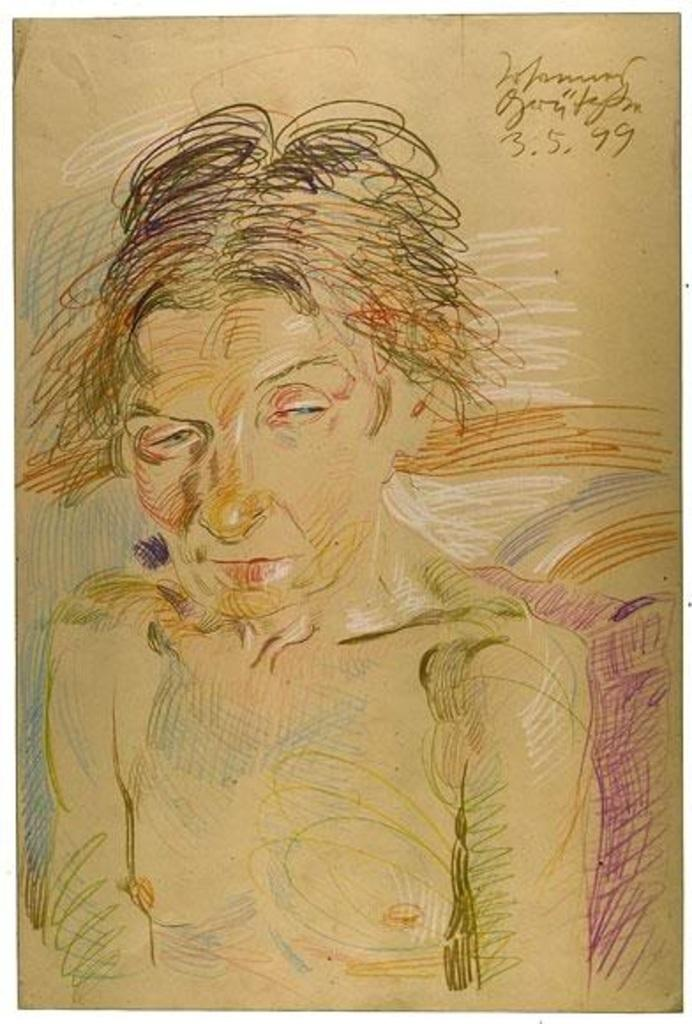What is depicted in the image? There is a drawing of a woman in the image. What is the woman doing in the drawing? The woman is leaning on a pillow in the drawing. Where is the woman located in the drawing? The woman is on a platform in the drawing. What additional information can be found on the platform? There are texts written on the platform in the top right corner of the image. What type of drum is the woman playing in the image? There is no drum present in the image; it features a drawing of a woman leaning on a pillow on a platform. 